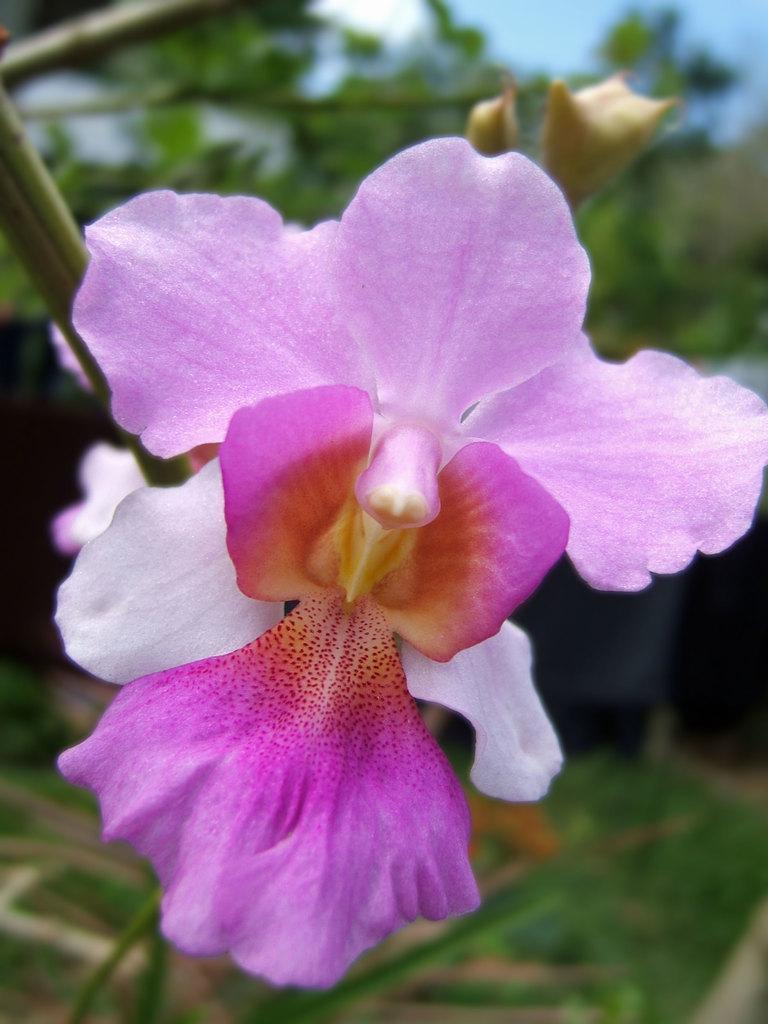Please provide a concise description of this image. This is a zoomed in picture. In the center we can see the flower. In the background we can see the plants and the sky. 